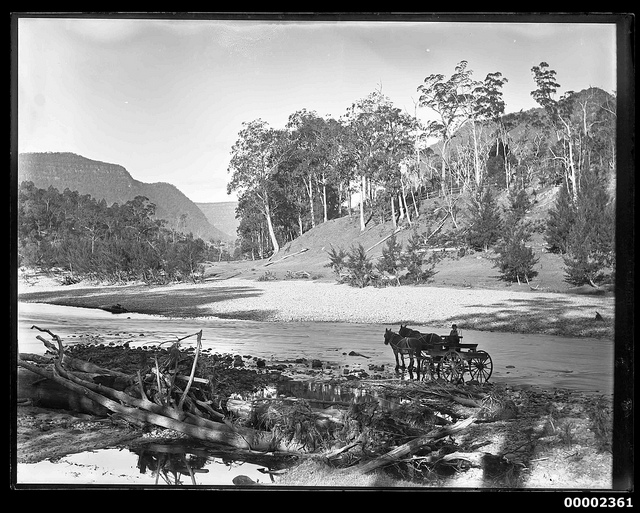<image>What is this person doing in the water? It is unknown what the person is doing in the water. They could be riding, standing, crossing, or doing nothing. What is this person doing in the water? I am not sure what the person is doing in the water. It can be seen that the person is riding, driving through it, or crossing. 